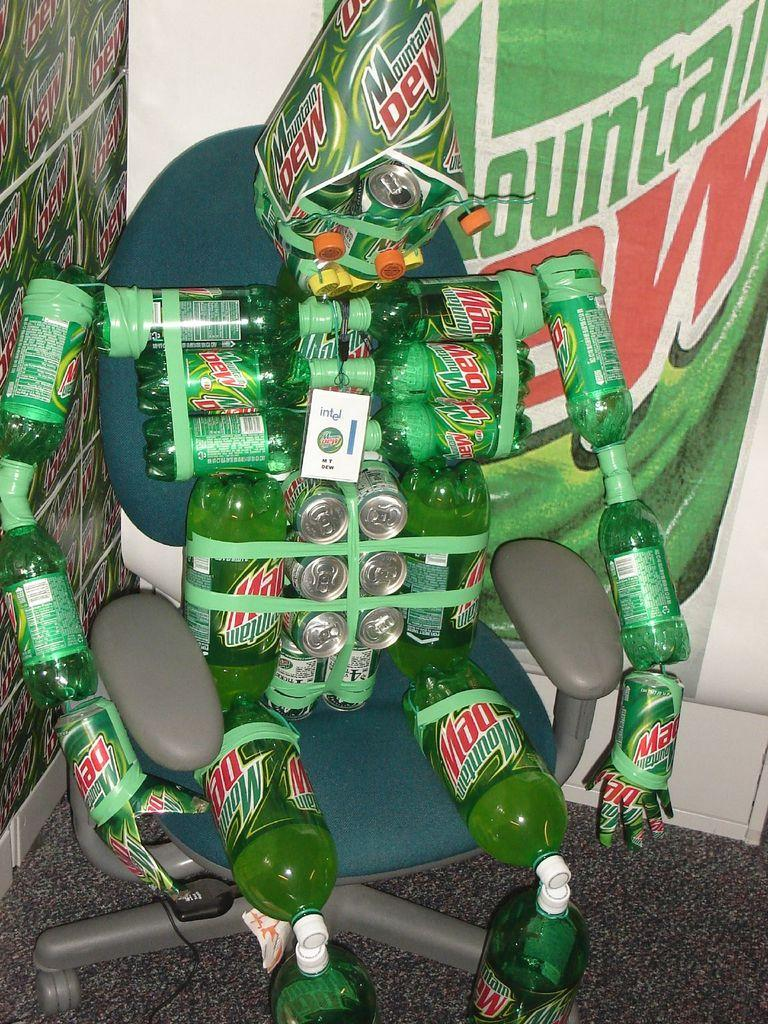<image>
Summarize the visual content of the image. A collection of Mountain Dew bottles and cans are arranged to resemble a humanoid sitting in an office chair. 